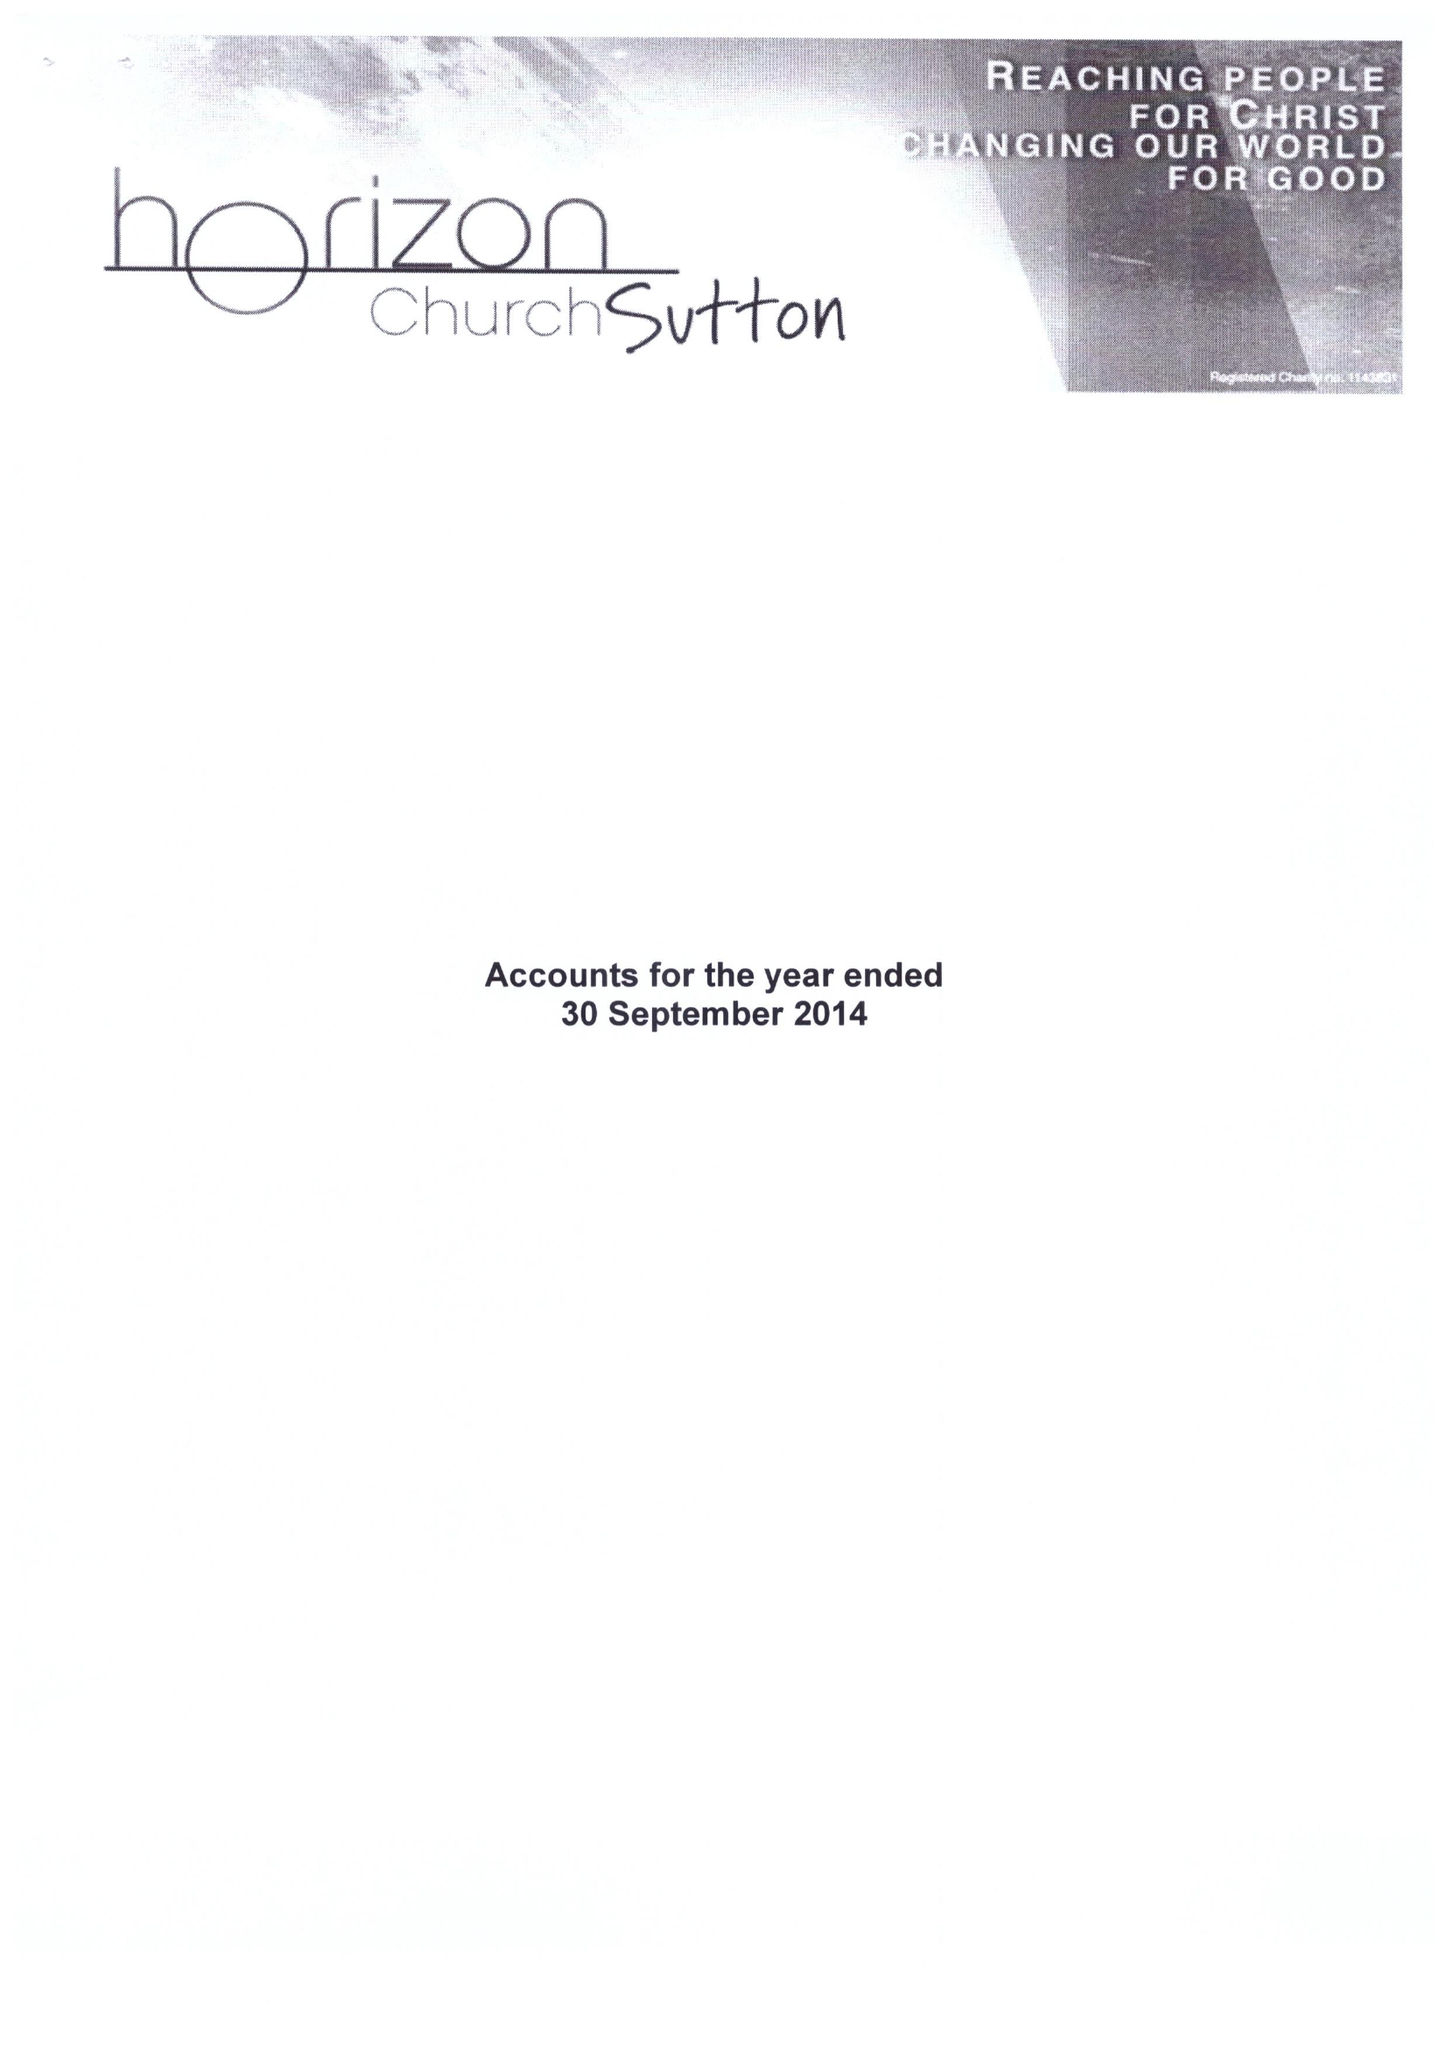What is the value for the address__street_line?
Answer the question using a single word or phrase. ASSEMBLY WALK 